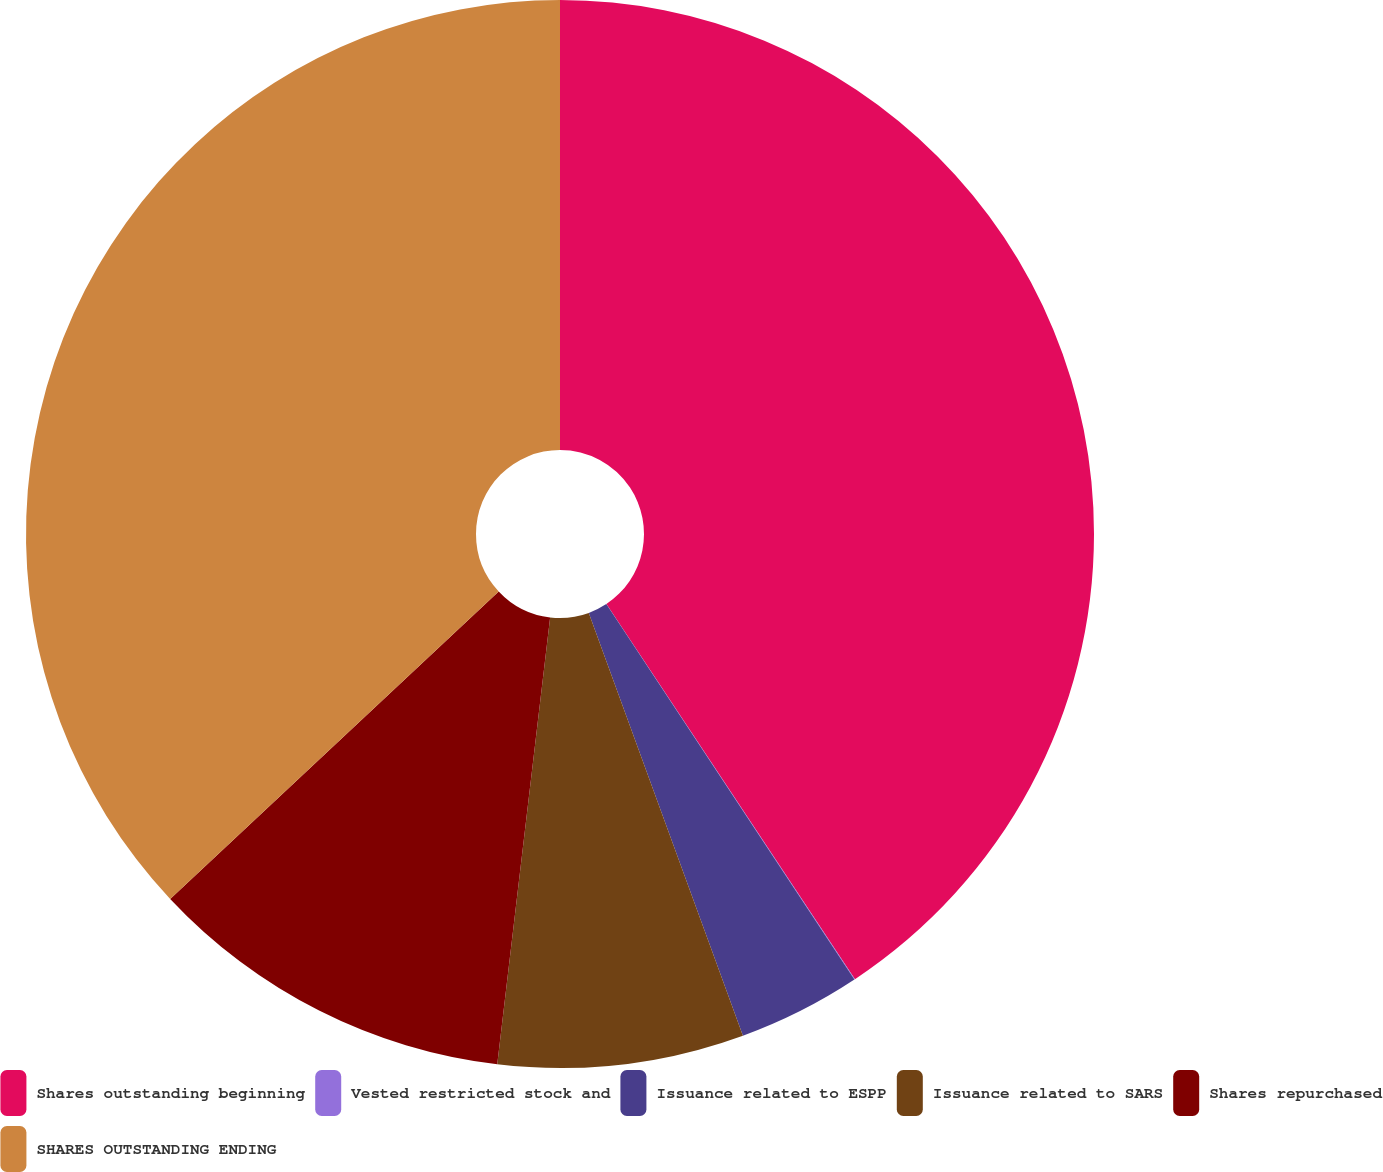Convert chart to OTSL. <chart><loc_0><loc_0><loc_500><loc_500><pie_chart><fcel>Shares outstanding beginning<fcel>Vested restricted stock and<fcel>Issuance related to ESPP<fcel>Issuance related to SARS<fcel>Shares repurchased<fcel>SHARES OUTSTANDING ENDING<nl><fcel>40.69%<fcel>0.02%<fcel>3.73%<fcel>7.44%<fcel>11.15%<fcel>36.98%<nl></chart> 